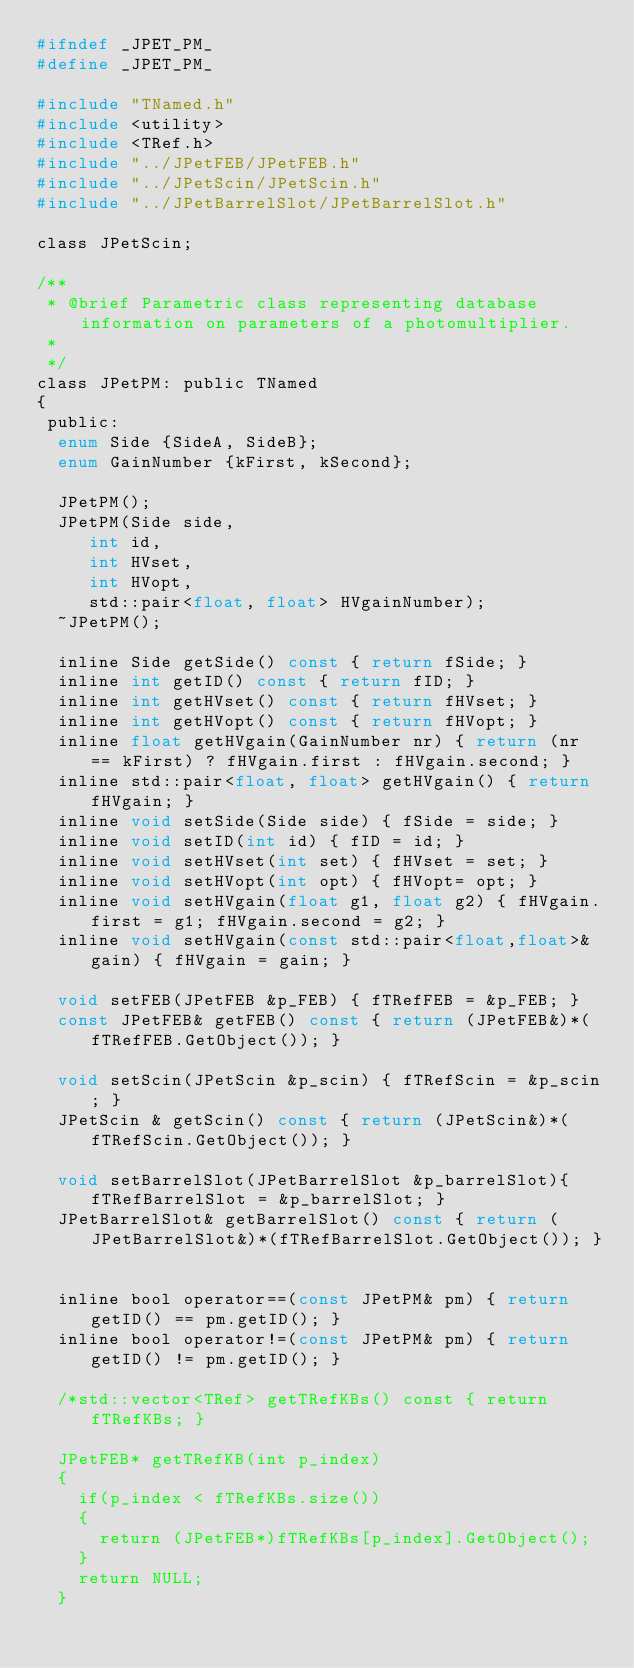<code> <loc_0><loc_0><loc_500><loc_500><_C_>#ifndef _JPET_PM_
#define _JPET_PM_

#include "TNamed.h"
#include <utility>
#include <TRef.h>
#include "../JPetFEB/JPetFEB.h"
#include "../JPetScin/JPetScin.h"
#include "../JPetBarrelSlot/JPetBarrelSlot.h"

class JPetScin;

/**
 * @brief Parametric class representing database information on parameters of a photomultiplier.
 *
 */
class JPetPM: public TNamed 
{
 public:
  enum Side {SideA, SideB};
  enum GainNumber {kFirst, kSecond};

  JPetPM();
  JPetPM(Side side,
	 int id,
	 int HVset,
	 int HVopt,
	 std::pair<float, float> HVgainNumber);
  ~JPetPM();

  inline Side getSide() const { return fSide; }
  inline int getID() const { return fID; }
  inline int getHVset() const { return fHVset; }
  inline int getHVopt() const { return fHVopt; }
  inline float getHVgain(GainNumber nr) { return (nr == kFirst) ? fHVgain.first : fHVgain.second; }
  inline std::pair<float, float> getHVgain() { return fHVgain; }
  inline void setSide(Side side) { fSide = side; }
  inline void setID(int id) { fID = id; }
  inline void setHVset(int set) { fHVset = set; }
  inline void setHVopt(int opt) { fHVopt= opt; }
  inline void setHVgain(float g1, float g2) { fHVgain.first = g1; fHVgain.second = g2; }
  inline void setHVgain(const std::pair<float,float>& gain) { fHVgain = gain; }

  void setFEB(JPetFEB &p_FEB) { fTRefFEB = &p_FEB; }
  const JPetFEB& getFEB() const { return (JPetFEB&)*(fTRefFEB.GetObject()); }
  
  void setScin(JPetScin &p_scin) { fTRefScin = &p_scin; }
  JPetScin & getScin() const { return (JPetScin&)*(fTRefScin.GetObject()); }

  void setBarrelSlot(JPetBarrelSlot &p_barrelSlot){ fTRefBarrelSlot = &p_barrelSlot; }
  JPetBarrelSlot& getBarrelSlot() const { return (JPetBarrelSlot&)*(fTRefBarrelSlot.GetObject()); }	
  
  inline bool operator==(const JPetPM& pm) { return getID() == pm.getID(); }
  inline bool operator!=(const JPetPM& pm) { return getID() != pm.getID(); }
  
  /*std::vector<TRef> getTRefKBs() const { return fTRefKBs; }

  JPetFEB* getTRefKB(int p_index)
  {
    if(p_index < fTRefKBs.size())
    {
      return (JPetFEB*)fTRefKBs[p_index].GetObject();
    }
    return NULL;
  }
  </code> 